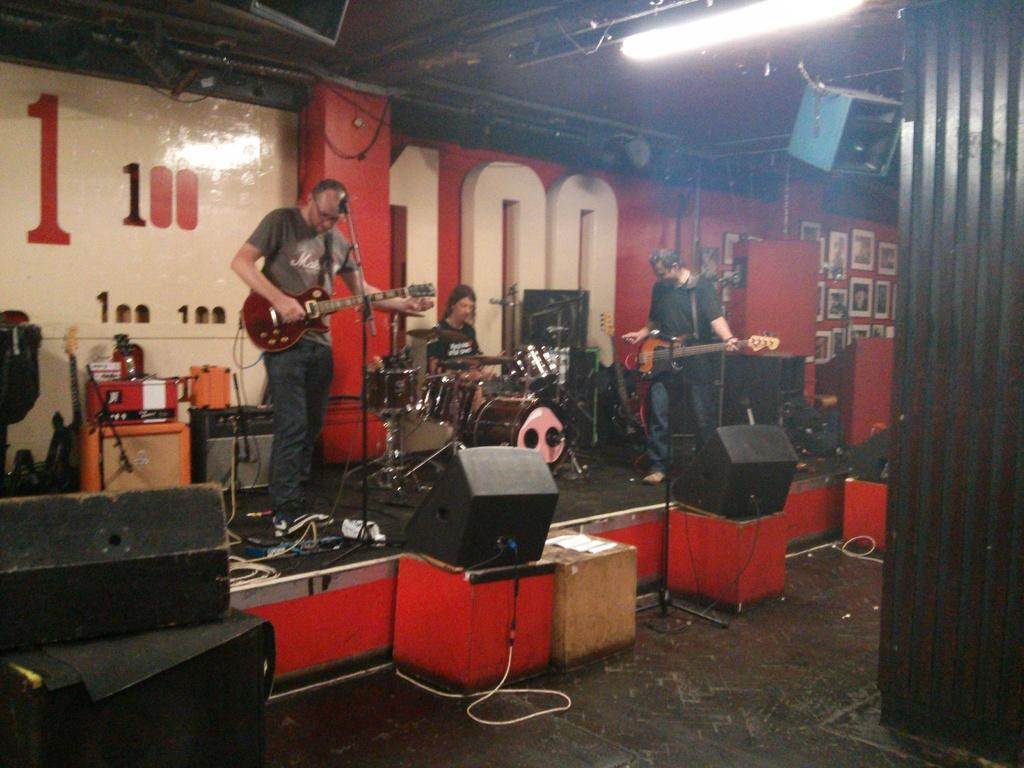How many people are in the group shown in the image? There is a group of people in the image. What are some of the people in the group doing? Some people in the group are playing guitars, and one person is playing drums. What might be used to amplify the sound of the musicians in the image? There are microphones in front of the musicians. Can you see any cobwebs in the image? There is no mention of cobwebs in the provided facts, so we cannot determine if any are present in the image. 